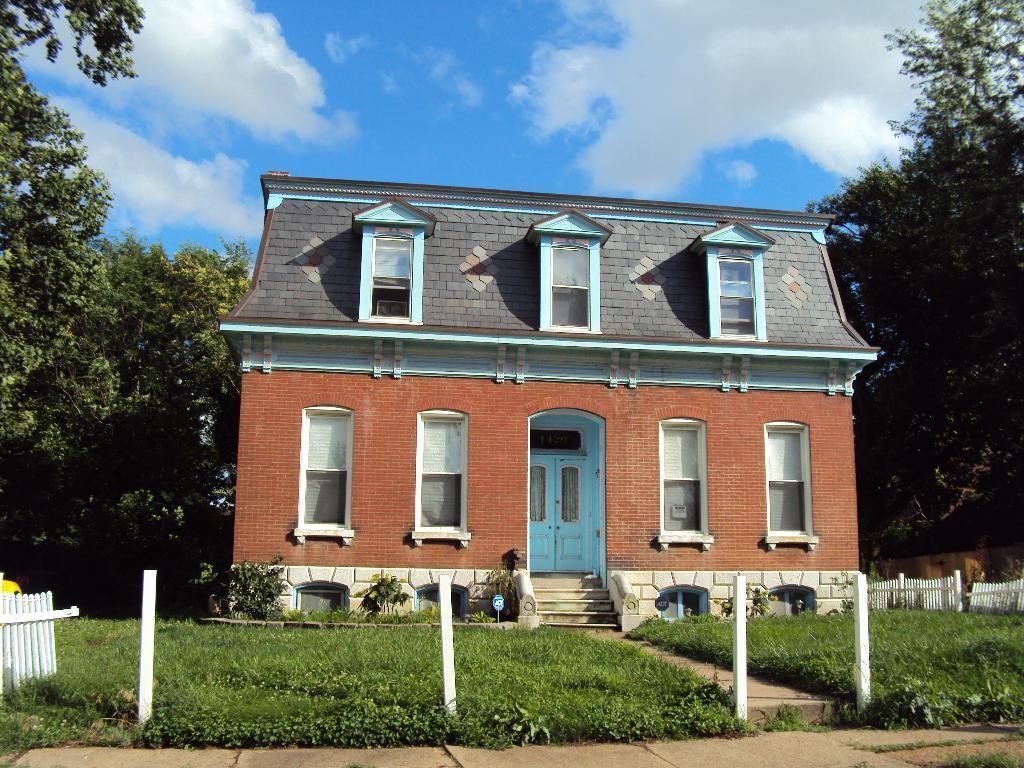How would you summarize this image in a sentence or two? In the center of the image we can see building, windows, door, trees, stairs, some plants, fencing, wall. At the bottom of the image we can see the ground. At the top of the image we can see the clouds are present in the sky. 